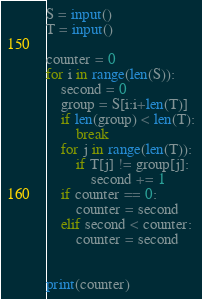<code> <loc_0><loc_0><loc_500><loc_500><_Python_>S = input()
T = input()

counter = 0
for i in range(len(S)):
    second = 0
    group = S[i:i+len(T)]
    if len(group) < len(T):
        break
    for j in range(len(T)):
        if T[j] != group[j]:
            second += 1
    if counter == 0:
        counter = second
    elif second < counter:
        counter = second


print(counter)</code> 